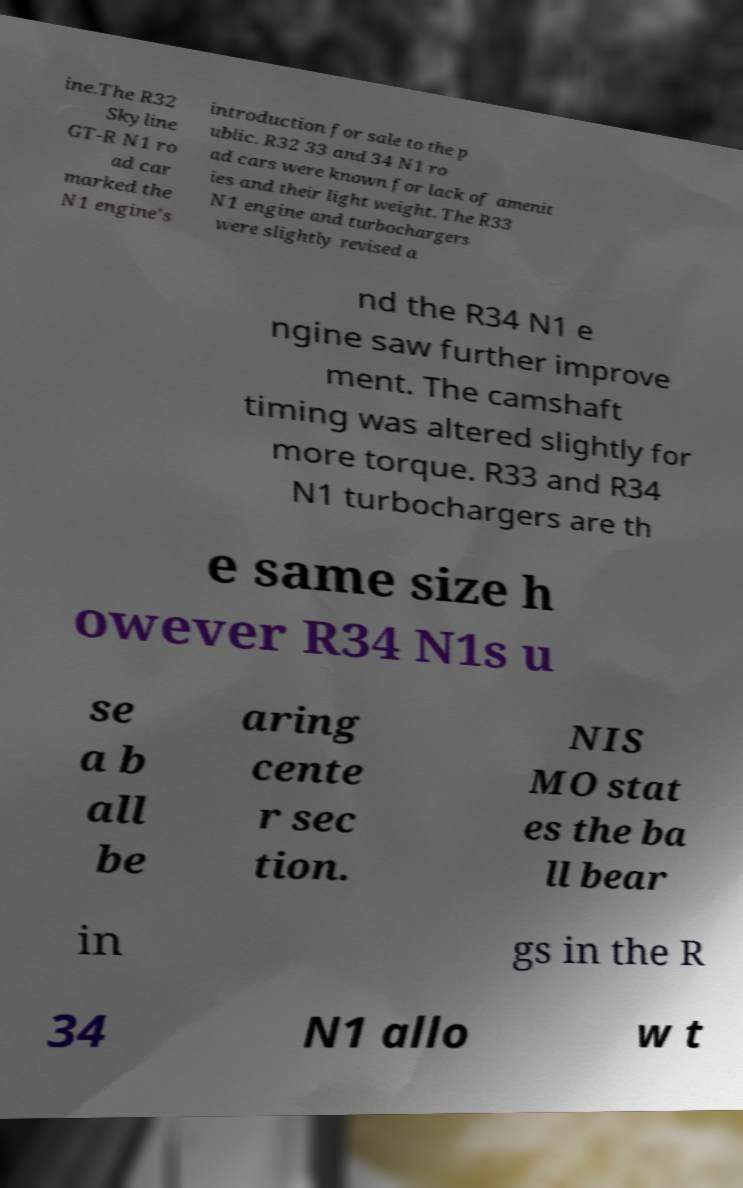Please identify and transcribe the text found in this image. ine.The R32 Skyline GT-R N1 ro ad car marked the N1 engine's introduction for sale to the p ublic. R32 33 and 34 N1 ro ad cars were known for lack of amenit ies and their light weight. The R33 N1 engine and turbochargers were slightly revised a nd the R34 N1 e ngine saw further improve ment. The camshaft timing was altered slightly for more torque. R33 and R34 N1 turbochargers are th e same size h owever R34 N1s u se a b all be aring cente r sec tion. NIS MO stat es the ba ll bear in gs in the R 34 N1 allo w t 